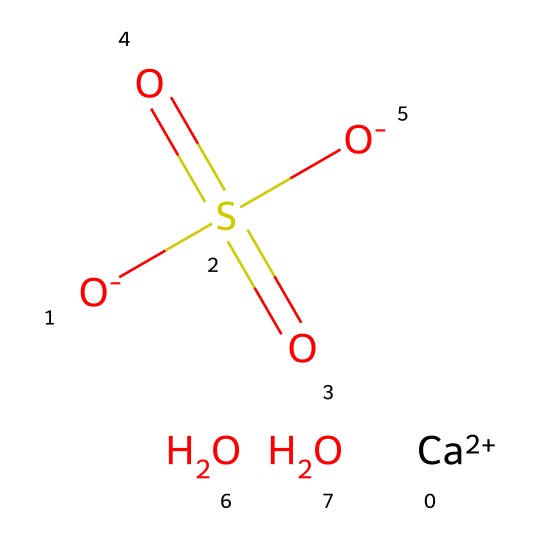What is the total number of oxygen atoms in this chemical? The chemical structure provided includes 4 oxygen atoms. Each "O" in the SMILES representation corresponds to an oxygen atom, and there are two in the sulfate group and two others in the additional hydroxyl parts of the compound.
Answer: four What does "Ca++" represent in this chemical? "Ca++" represents calcium ions with a +2 oxidation state, which indicates that calcium has lost two electrons and exists as a cation in the chemical formula.
Answer: calcium ion How many sulfate groups are present in this chemical? The sulfate group is indicated by "S(=O)(=O)[O-]", which signifies that there is one sulfate group attached to the calcium and hydroxyl parts.
Answer: one What is the charge of the calcium ion in this compound? The calcium ion is represented as "Ca++", indicating a positive charge of +2 due to the loss of two electrons.
Answer: +2 What kind of chemical is represented in this SMILES structure? The structure corresponds to a dye, specifically a water-soluble dye used in markers, which includes a calcium compound and a sulfate group, typically indicating its use in non-permanent applications.
Answer: dye Which part of this chemical contributes to its solvability in water? The presence of the sulfate group (S(=O)(=O)[O-]) and hydroxyl groups (O) increases the polarity of the compound, allowing it to interact with water and thus enhance its solubility.
Answer: sulfate group 